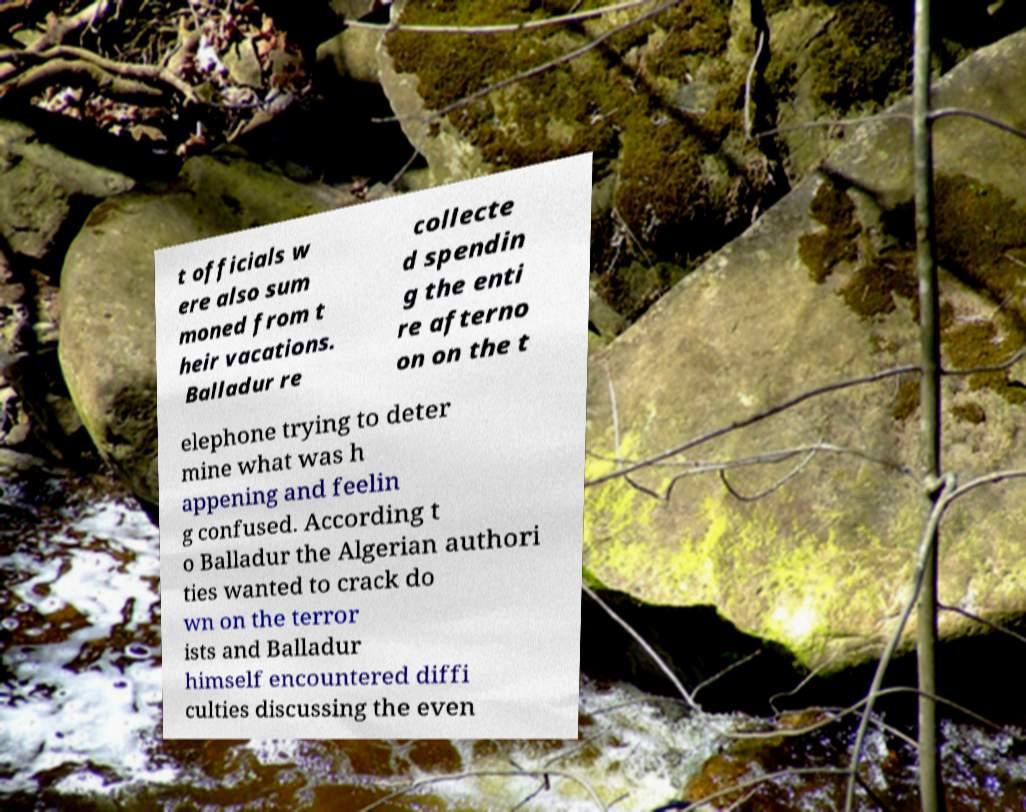What messages or text are displayed in this image? I need them in a readable, typed format. t officials w ere also sum moned from t heir vacations. Balladur re collecte d spendin g the enti re afterno on on the t elephone trying to deter mine what was h appening and feelin g confused. According t o Balladur the Algerian authori ties wanted to crack do wn on the terror ists and Balladur himself encountered diffi culties discussing the even 